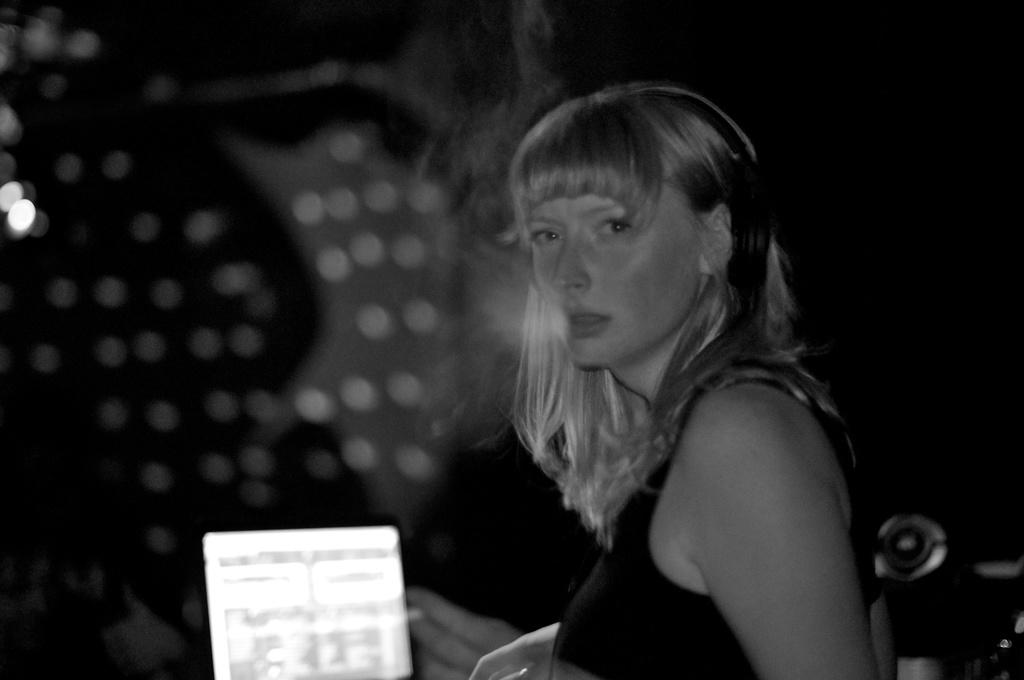What is the color scheme of the image? The image is black and white. Who is present in the image? There is a woman in the image. What is the woman doing in the image? The woman is holding an object. What can be seen in the background of the image? The background of the image is dark. What type of interest can be seen growing in the image? There is no interest growing in the image, as the image is black and white and does not depict any plants or vegetation. Can you tell me how many grapes are on the woman's plate in the image? There is no plate or grapes present in the image; the woman is holding an object, but it is not specified as a plate or containing grapes. 